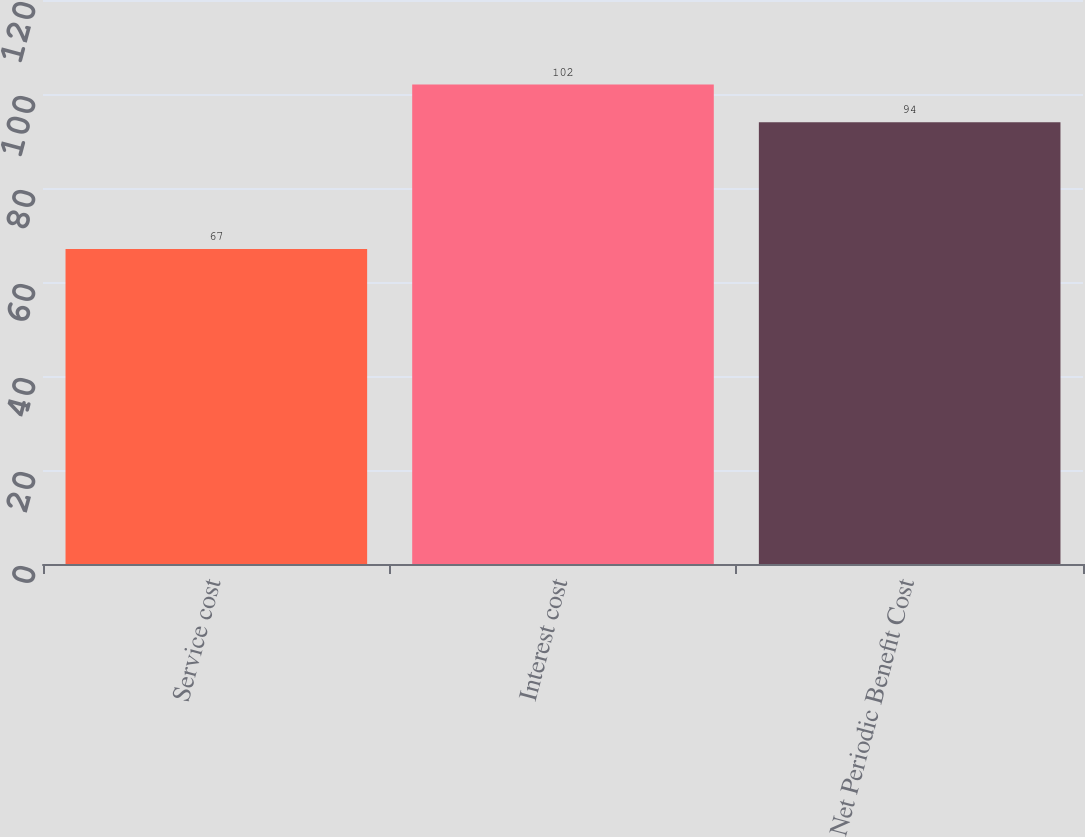<chart> <loc_0><loc_0><loc_500><loc_500><bar_chart><fcel>Service cost<fcel>Interest cost<fcel>Net Periodic Benefit Cost<nl><fcel>67<fcel>102<fcel>94<nl></chart> 